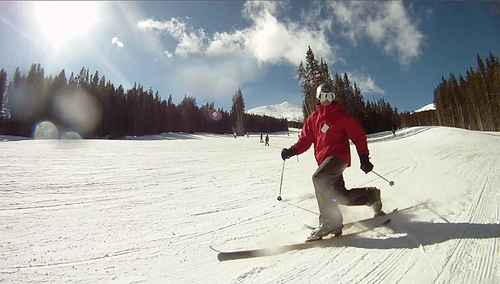What kind of activity is the person in the photo doing? The person in the image appears to be engaged in alpine skiing, a winter sport where participants slide down snow-covered slopes on skis with fixed-heel bindings. It's an exhilarating sport that offers both physical exercise and the pleasure of experiencing beautiful, snowy landscapes. 